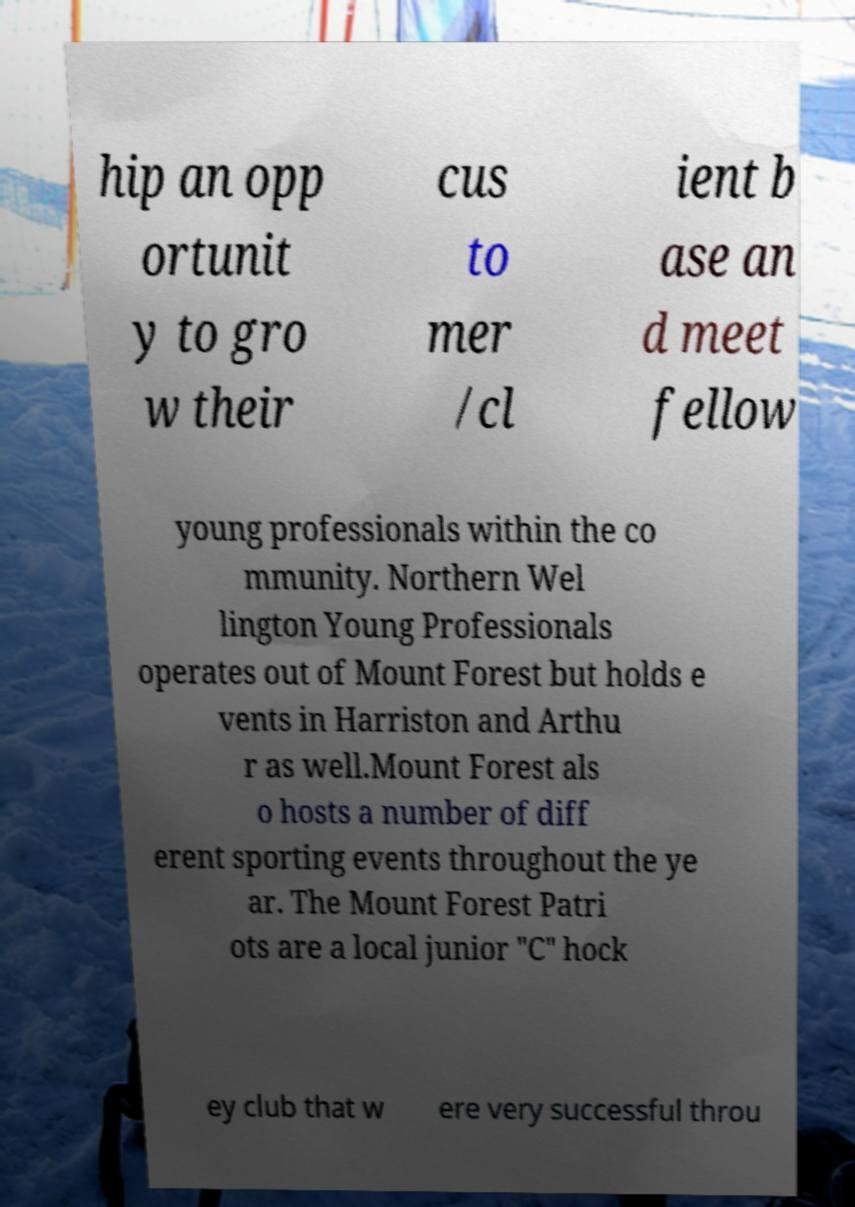There's text embedded in this image that I need extracted. Can you transcribe it verbatim? hip an opp ortunit y to gro w their cus to mer /cl ient b ase an d meet fellow young professionals within the co mmunity. Northern Wel lington Young Professionals operates out of Mount Forest but holds e vents in Harriston and Arthu r as well.Mount Forest als o hosts a number of diff erent sporting events throughout the ye ar. The Mount Forest Patri ots are a local junior "C" hock ey club that w ere very successful throu 